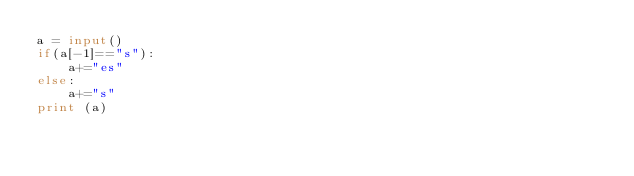Convert code to text. <code><loc_0><loc_0><loc_500><loc_500><_Python_>a = input()
if(a[-1]=="s"):
    a+="es"
else:
    a+="s"
print (a)
</code> 